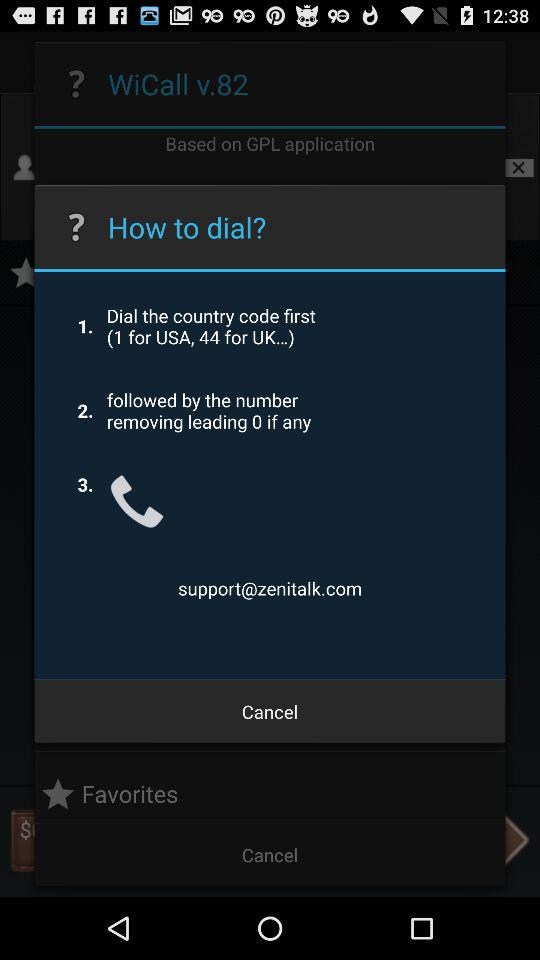What is the email address? The email address is support@zenitalk.com. 